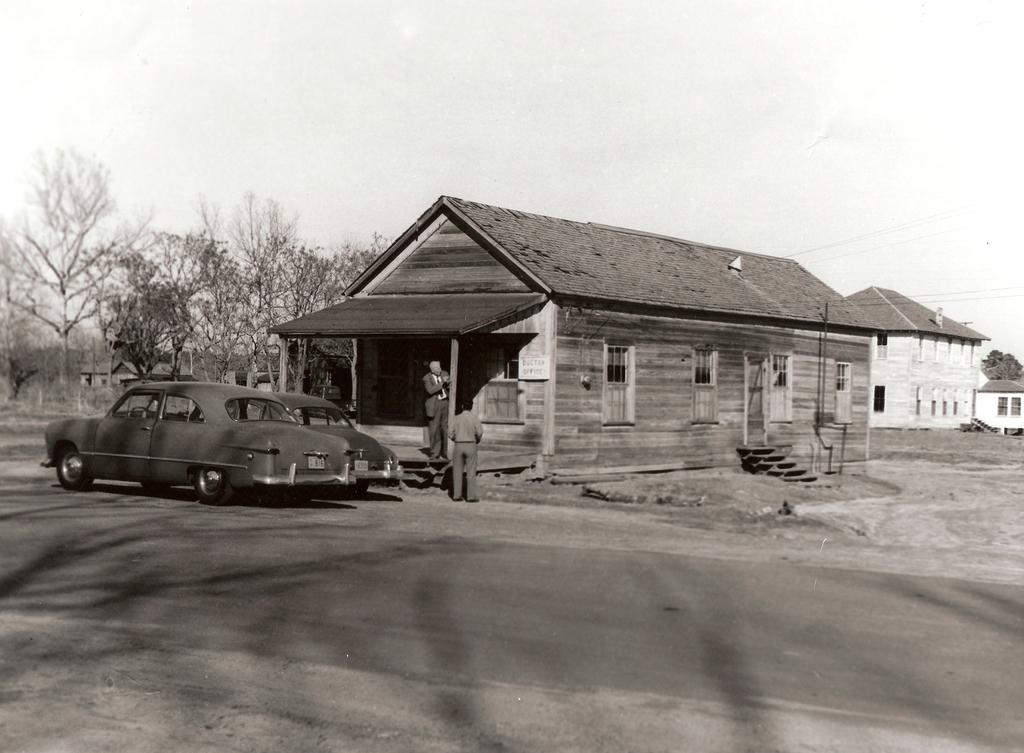How many people are present in the image? There are two people in the image. What type of structures can be seen in the image? There are houses in the image. What architectural feature is visible in the houses? Windows are visible in the image. What type of vehicles can be seen on the road in the image? There are cars on the road in the image. What type of vegetation is present in the image? There are trees in the image. What part of the natural environment is visible in the image? The sky is visible in the image. What type of stamp can be seen on the decision made by the people in the image? There is no stamp or decision made by the people in the image; it only shows two people, houses, windows, cars, trees, and the sky. 